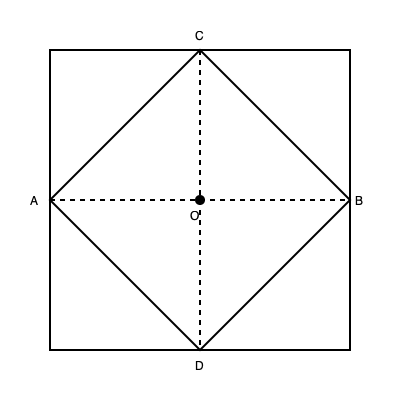The diagram represents an unfolded origami shape symbolizing athletic discipline. If the shape is folded along the dotted lines to form a three-dimensional object, which point will coincide with point O? To solve this spatial reasoning problem, let's follow these steps:

1. Understand the folding process:
   - The dotted lines represent fold lines.
   - The shape will be folded inward along these lines.

2. Analyze the symmetry:
   - The diagram is symmetrical, with point O at the center.
   - The dotted lines intersect at point O.

3. Identify the folding action:
   - When folded, the outer corners (A, B, C, D) will move towards the center (O).

4. Consider the distance from corners to center:
   - All four corners (A, B, C, D) are equidistant from O.
   - This is evident from the symmetry of the square and the diamond shape within it.

5. Visualize the folded shape:
   - As the shape is folded, all four corners will meet at the center point O.

6. Conclude:
   - Since all corners meet at O, any of the four corners (A, B, C, or D) will coincide with O.

7. Choose the most precise answer:
   - While all corners meet at O, the question asks for a single point.
   - In origami and geometric conventions, we often prioritize the top point.
   - Point C is at the top of the diagram and would be the topmost point when folded.

Therefore, point C will coincide with point O when the shape is folded.
Answer: C 